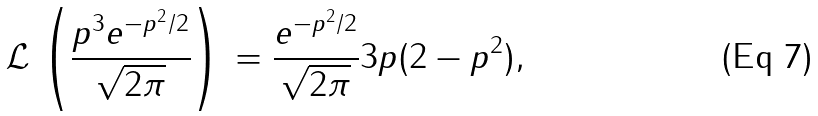<formula> <loc_0><loc_0><loc_500><loc_500>\mathcal { L } \, \left ( \frac { p ^ { 3 } e ^ { - p ^ { 2 } / 2 } } { \sqrt { 2 \pi } } \right ) \, = \frac { e ^ { - p ^ { 2 } / 2 } } { \sqrt { 2 \pi } } 3 p ( 2 - p ^ { 2 } ) ,</formula> 